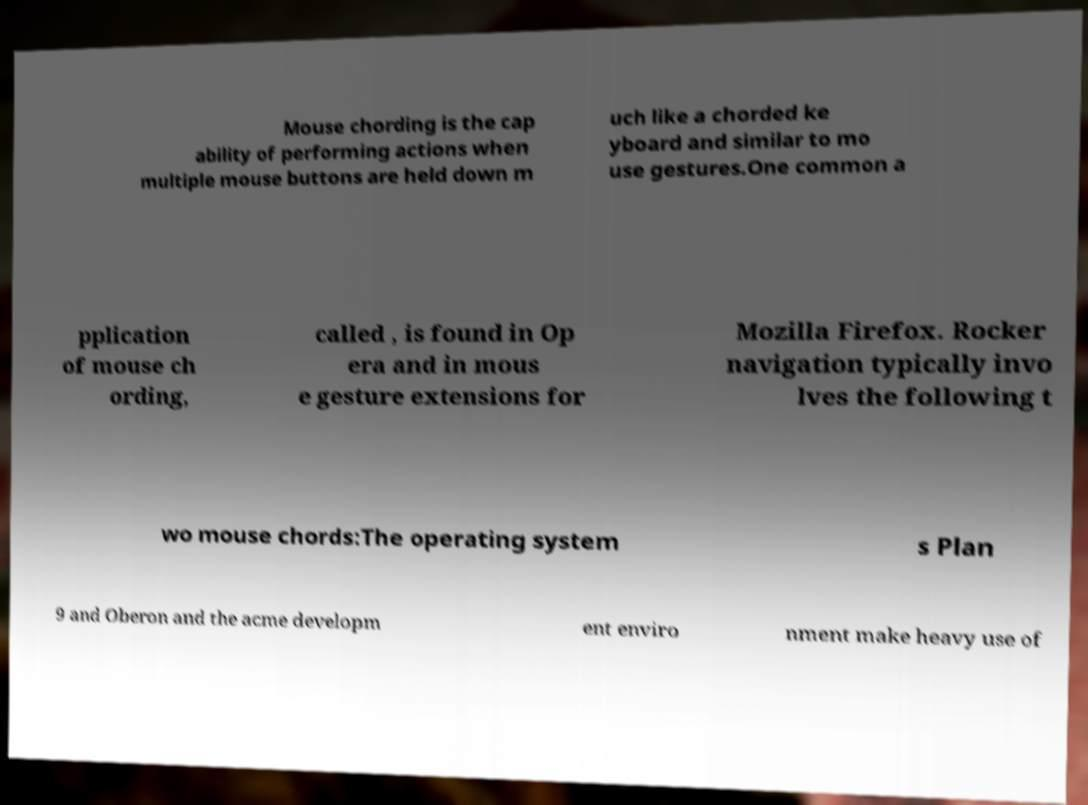Can you accurately transcribe the text from the provided image for me? Mouse chording is the cap ability of performing actions when multiple mouse buttons are held down m uch like a chorded ke yboard and similar to mo use gestures.One common a pplication of mouse ch ording, called , is found in Op era and in mous e gesture extensions for Mozilla Firefox. Rocker navigation typically invo lves the following t wo mouse chords:The operating system s Plan 9 and Oberon and the acme developm ent enviro nment make heavy use of 